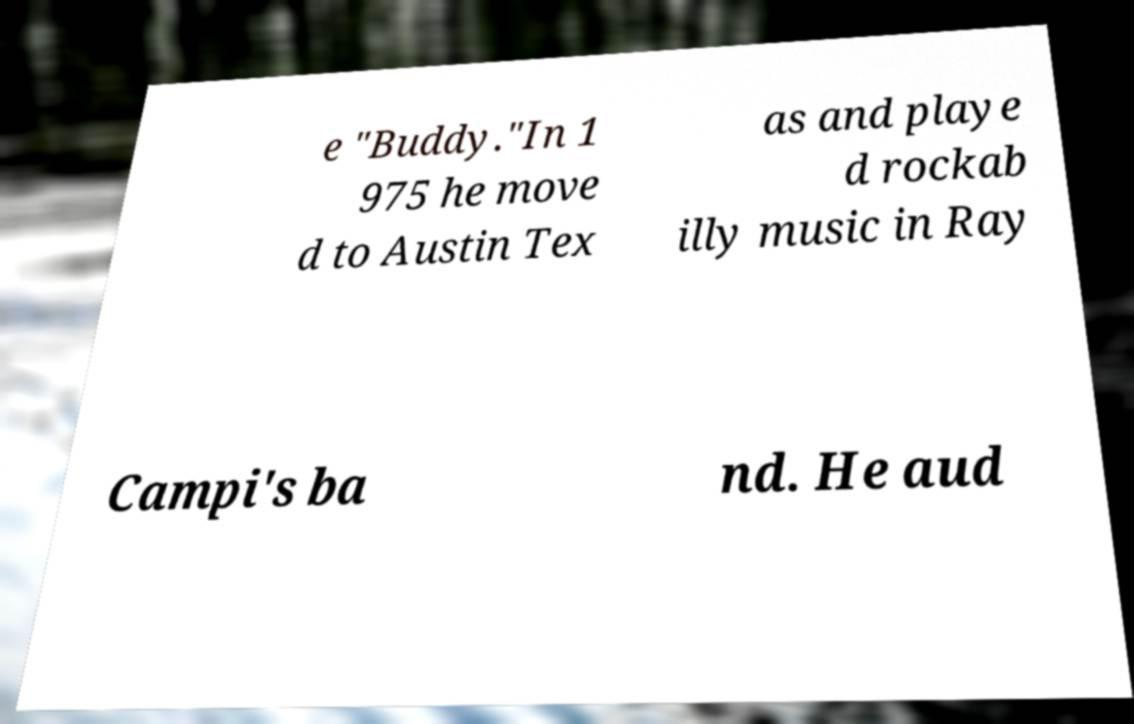For documentation purposes, I need the text within this image transcribed. Could you provide that? e "Buddy."In 1 975 he move d to Austin Tex as and playe d rockab illy music in Ray Campi's ba nd. He aud 